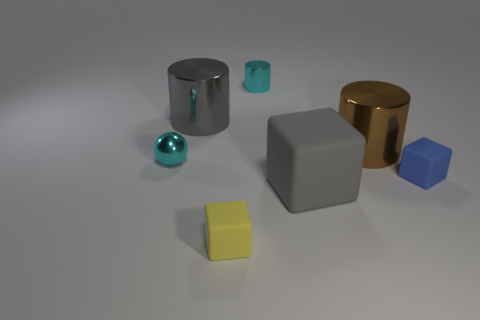Add 1 blue balls. How many objects exist? 8 Subtract all cylinders. How many objects are left? 4 Add 1 big cubes. How many big cubes exist? 2 Subtract 0 green cylinders. How many objects are left? 7 Subtract all large blue metallic spheres. Subtract all tiny balls. How many objects are left? 6 Add 3 large shiny cylinders. How many large shiny cylinders are left? 5 